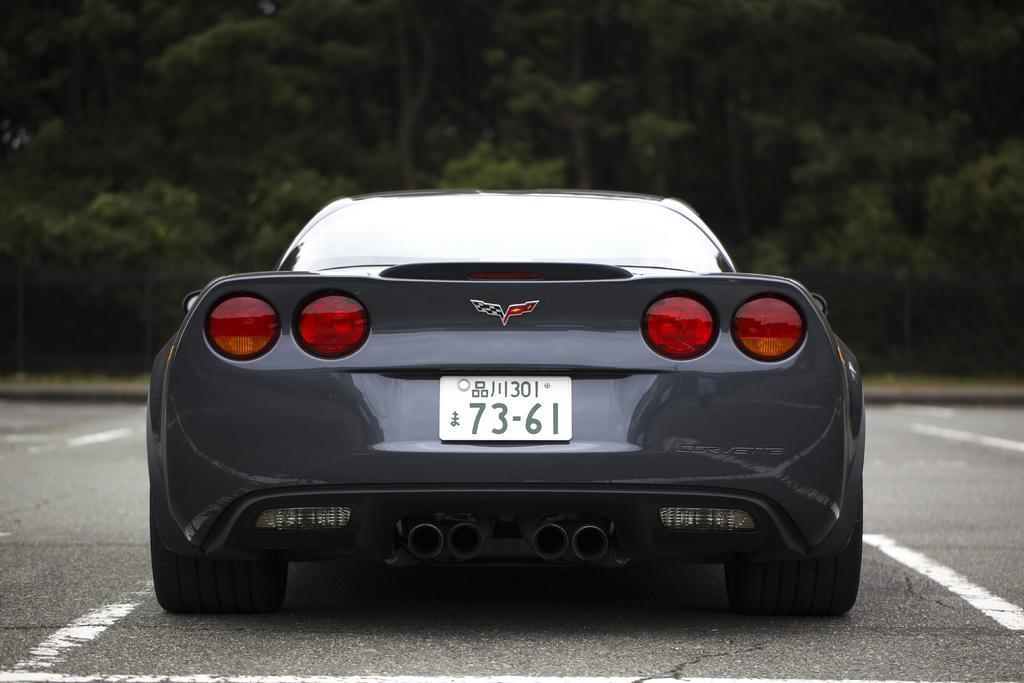<image>
Write a terse but informative summary of the picture. the back side of a black sports car with license plate 73-61 